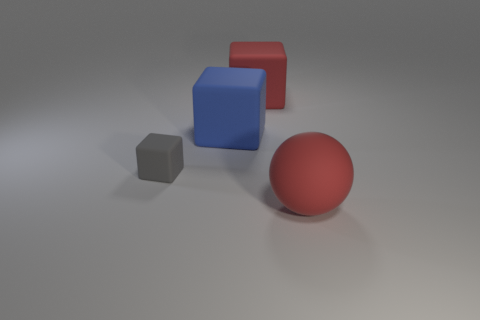Subtract all gray cubes. Subtract all red cylinders. How many cubes are left? 2 Add 2 small gray rubber objects. How many objects exist? 6 Subtract all cubes. How many objects are left? 1 Add 4 blue matte objects. How many blue matte objects exist? 5 Subtract 0 red cylinders. How many objects are left? 4 Subtract all big red balls. Subtract all red objects. How many objects are left? 1 Add 1 large blue blocks. How many large blue blocks are left? 2 